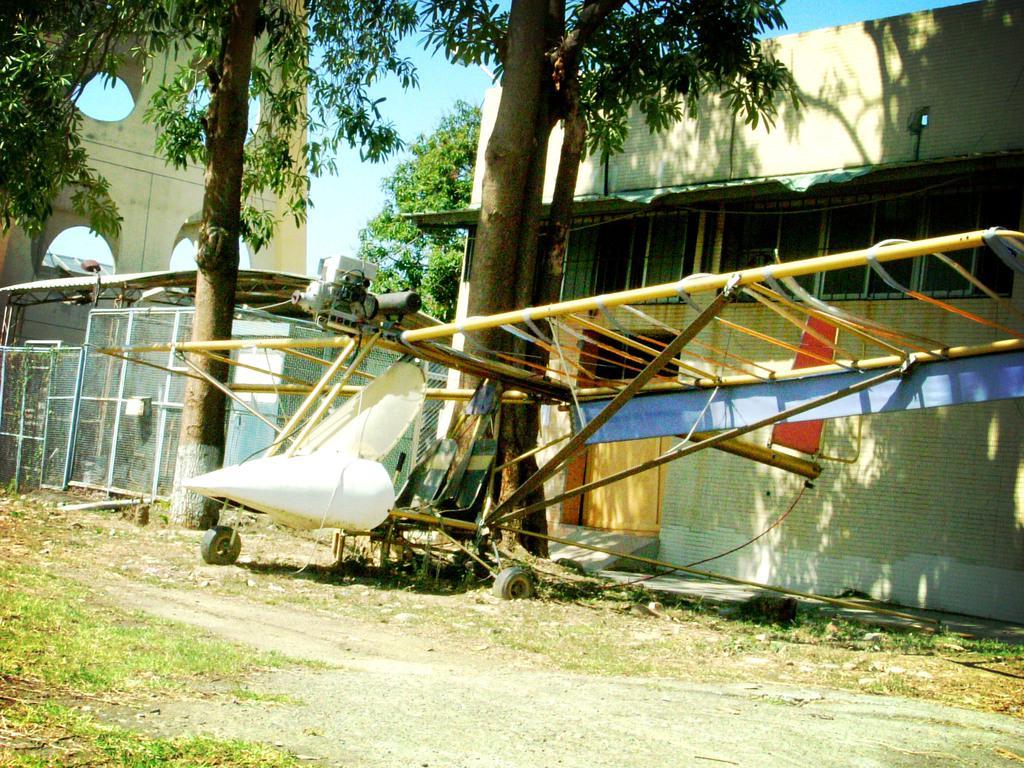Could you give a brief overview of what you see in this image? In this image I can see a vehicle in white color and I can also see a ladder. Background I can see trees in green color, fencing, a building in white color, few windows and the sky is in blue color. 